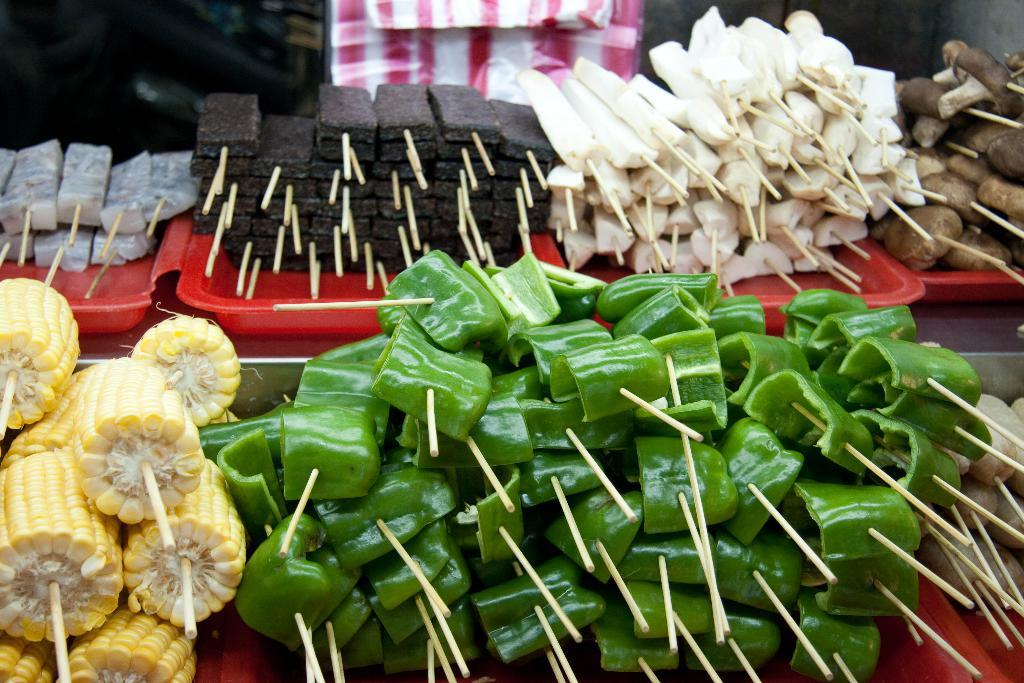What can be seen on the trays in the image? There are food items on the trays in the image. Can you describe the background of the image? The background of the image is blurry. How many stars can be seen in the image? There are no stars visible in the image. What type of pencil is being used to draw on the trays in the image? There are no pencils or drawings present in the image. 